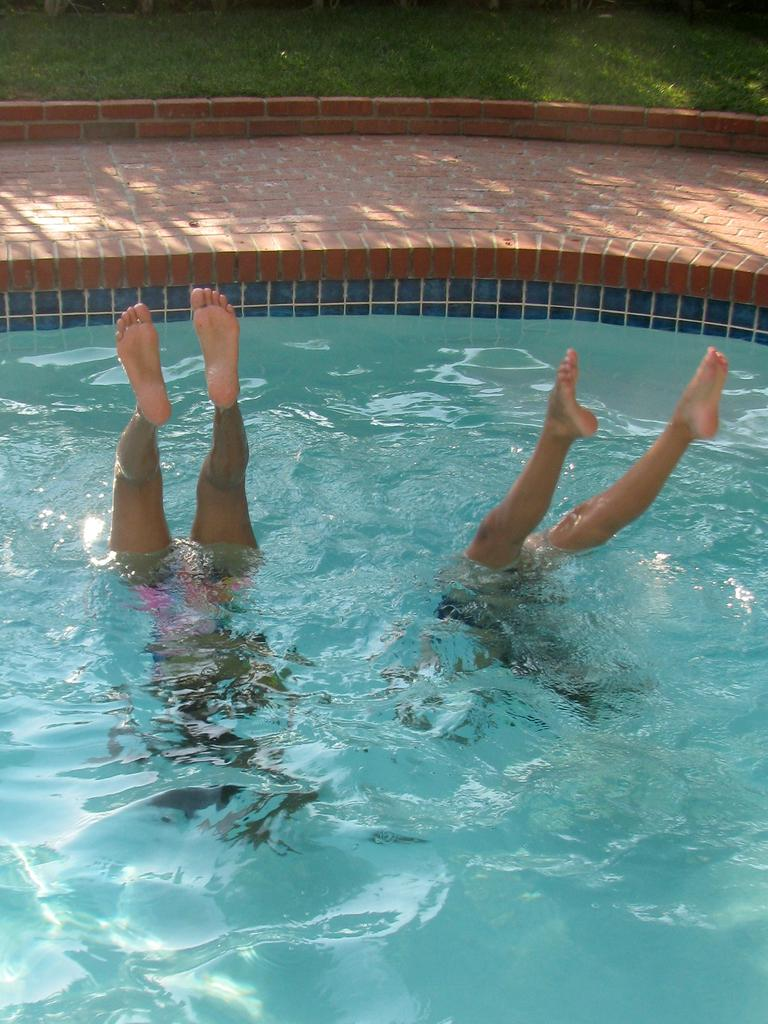What are the people in the image doing? The people in the image are swimming in the swimming pool. What type of surface is behind the swimming pool? There is grass on the ground behind the swimming pool. What color crayon is being used to draw on the dogs in the image? There are no crayons or dogs present in the image; it features people swimming in a swimming pool with grass in the background. 